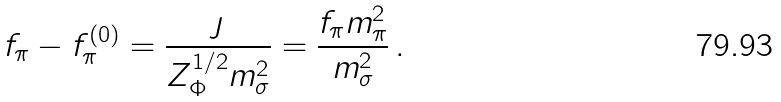<formula> <loc_0><loc_0><loc_500><loc_500>f _ { \pi } - f _ { \pi } ^ { ( 0 ) } = \frac { \jmath } { Z _ { \Phi } ^ { 1 / 2 } m _ { \sigma } ^ { 2 } } = \frac { f _ { \pi } m _ { \pi } ^ { 2 } } { m _ { \sigma } ^ { 2 } } \, .</formula> 